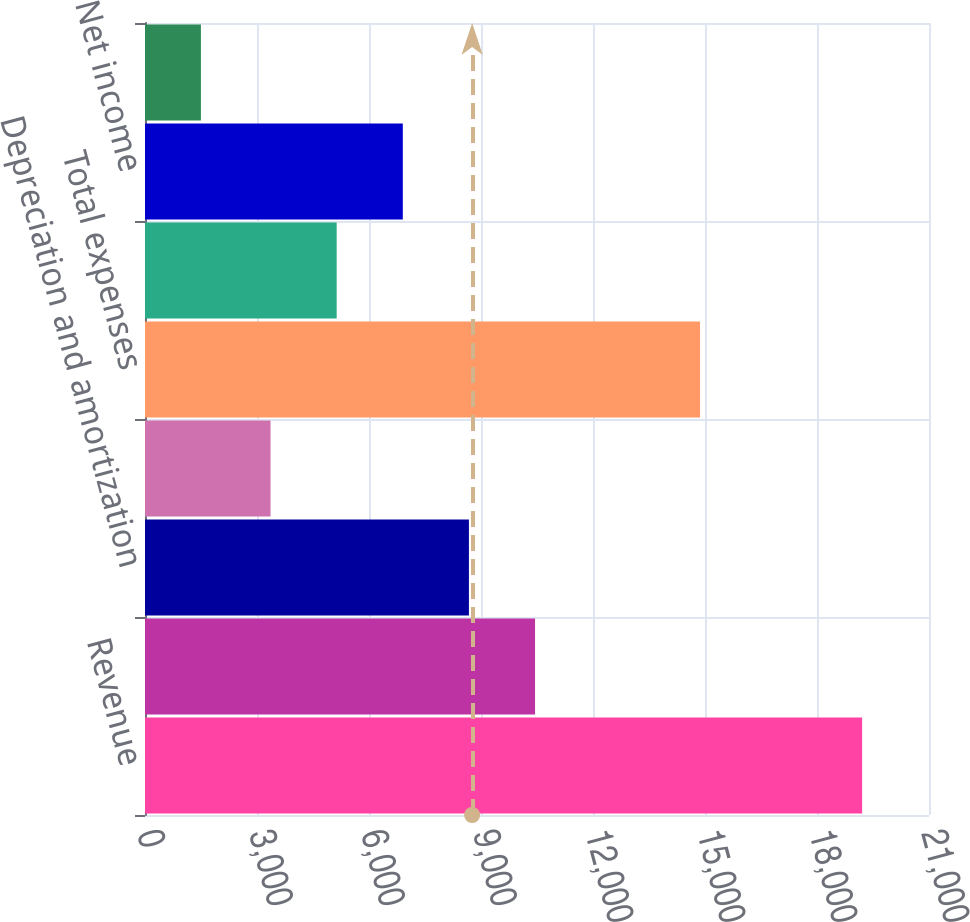Convert chart to OTSL. <chart><loc_0><loc_0><loc_500><loc_500><bar_chart><fcel>Revenue<fcel>Other operating expenses<fcel>Depreciation and amortization<fcel>Interest expense<fcel>Total expenses<fcel>Net income before gain on sale<fcel>Net income<fcel>Our share of net income from<nl><fcel>19209<fcel>10447.4<fcel>8676.3<fcel>3363<fcel>14868<fcel>5134.1<fcel>6905.2<fcel>1498<nl></chart> 